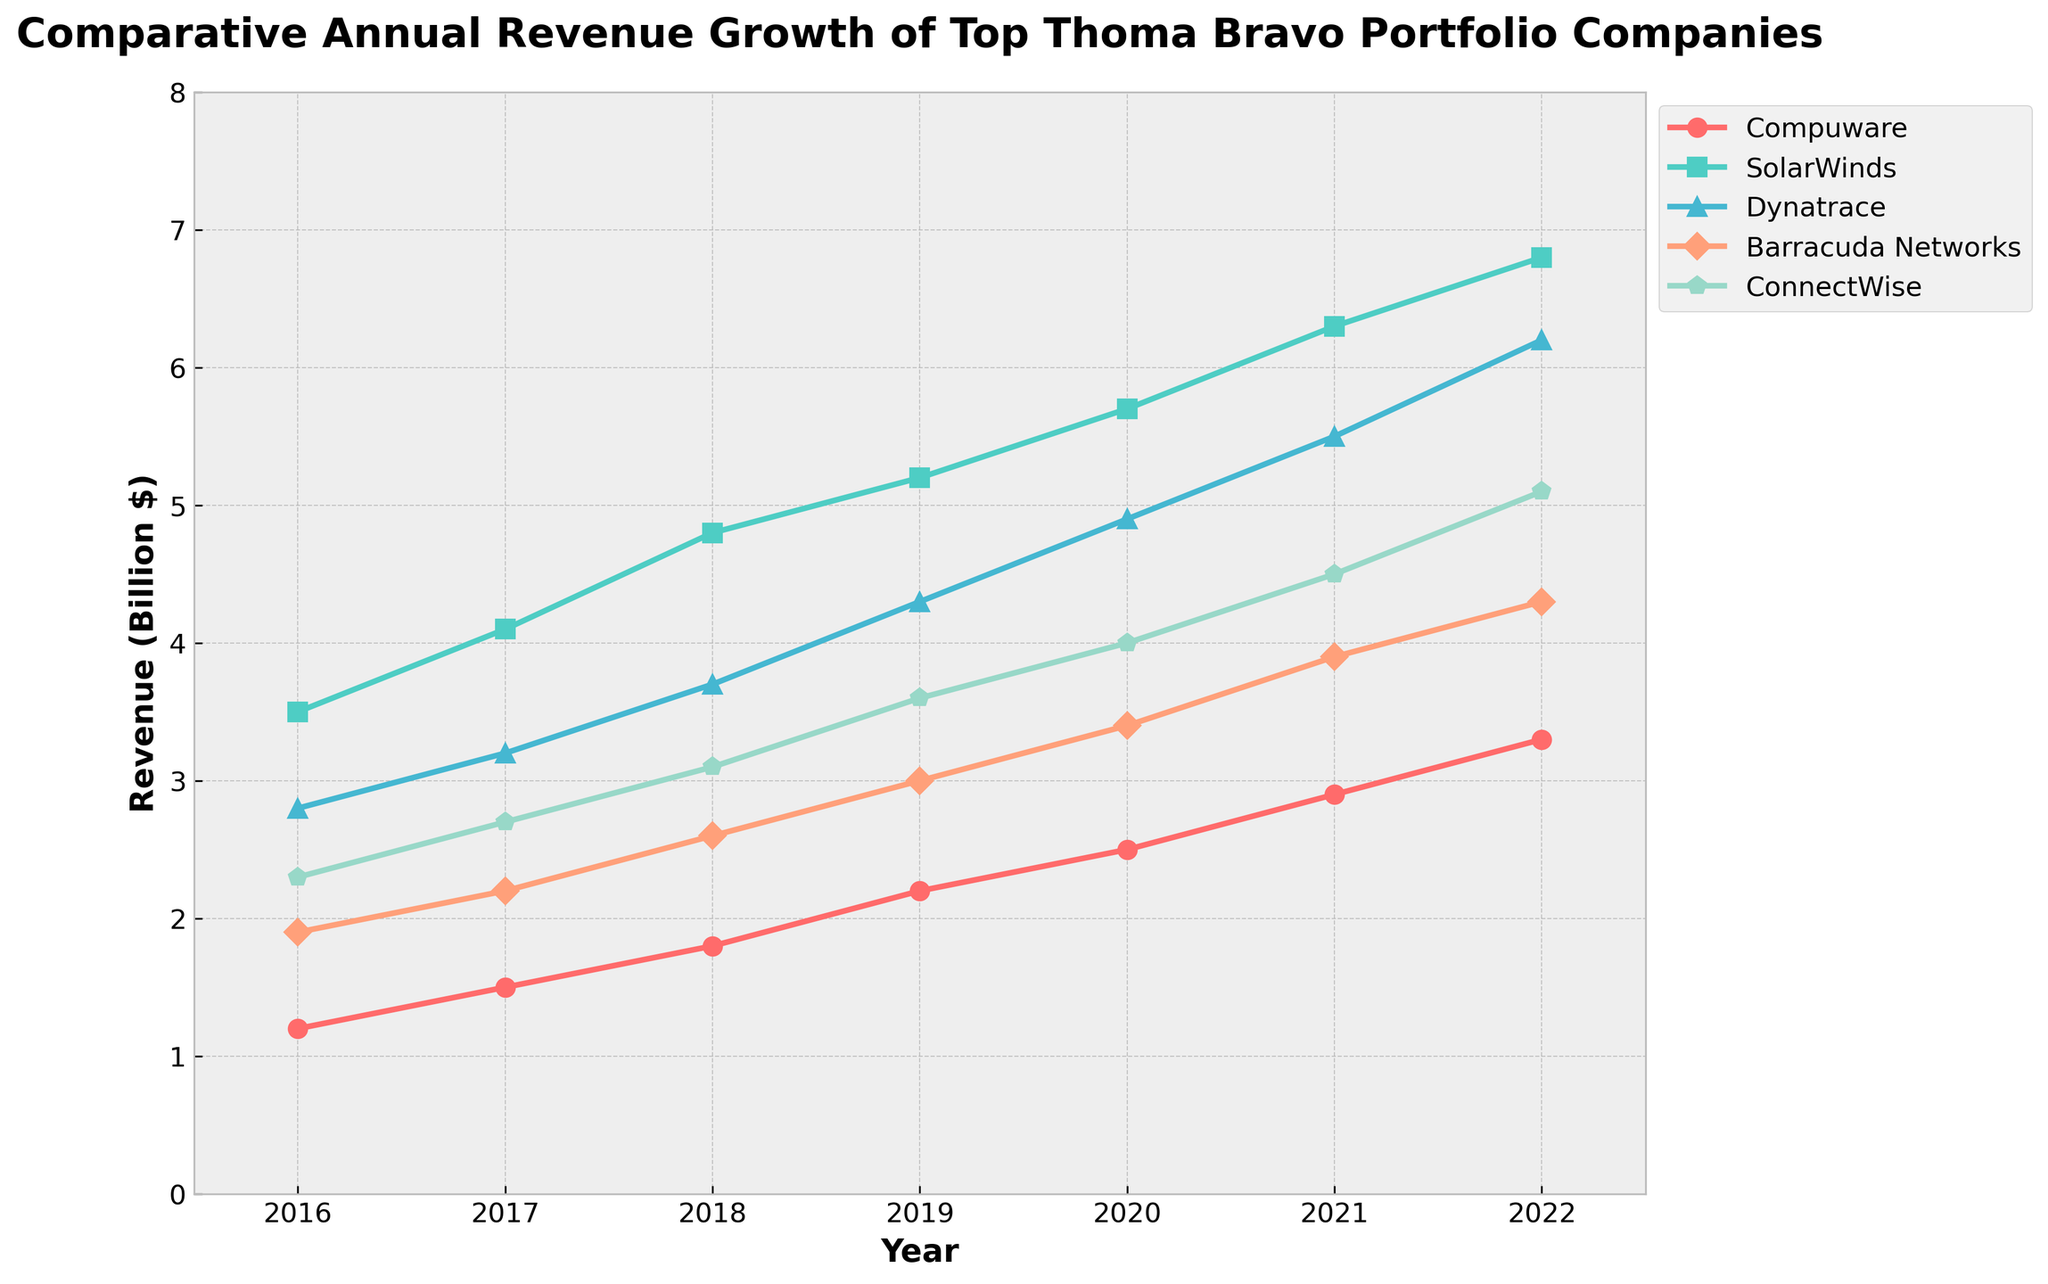Which company had the highest revenue in 2022? By observing the plotted lines for the year 2022 and comparing their end points, we see that SolarWinds had the highest revenue.
Answer: SolarWinds Which company had the least revenue growth from 2016 to 2022? Comparing the difference in revenues from 2016 to 2022 for each company, Compuware went from 1.2 to 3.3, SolarWinds from 3.5 to 6.8, Dynatrace from 2.8 to 6.2, Barracuda Networks from 1.9 to 4.3, and ConnectWise from 2.3 to 5.1. Barracuda Networks shows the least increase (2.4).
Answer: Barracuda Networks Which companies had a revenue of at least 5 billion dollars in 2022? Observing the year 2022 and noting which lines are at or above the 5 billion mark, SolarWinds and Dynatrace meet this criterion.
Answer: SolarWinds, Dynatrace Did any company have a steady (linear) revenue growth from 2016 to 2022? By inspecting the trend of each line across the years, it can be noted that all companies show a generally upward trend; however, no company displays perfectly steady (linear) growth without fluctuations.
Answer: None In which year did Dynatrace surpass a revenue of 4 billion dollars? Following Dynatrace’s growth line across the years, it crosses the 4 billion mark between 2018 and 2019.
Answer: 2019 Which company experienced the highest rate of revenue growth from 2016 to 2022? By comparing the slopes of the lines over the entire period, SolarWinds shows the highest rate of growth, starting at 3.5 and ending at 6.8.
Answer: SolarWinds What is the approximate average revenue of ConnectWise over the years displayed? Adding the revenue values of ConnectWise from 2016 to 2022: 2.3 + 2.7 + 3.1 + 3.6 + 4.0 + 4.5 + 5.1 = 25.3, then dividing by the number of years (7): 25.3 / 7 ≈ 3.61.
Answer: 3.61 Between which consecutive years did Compuware show the greatest increase in revenue? By checking the differences between consecutive years for Compuware: 1.5 - 1.2 = 0.3, 1.8 - 1.5 = 0.3, 2.2 - 1.8 = 0.4, 2.5 - 2.2 = 0.3, 2.9 - 2.5 = 0.4, and 3.3 - 2.9 = 0.4. Compuware had the greatest increase (0.4) between 2018-2019, 2020-2021, and 2021-2022.
Answer: 2018-2019, 2020-2021, 2021-2022 How did SolarWinds' revenue change from 2019 to 2020? Observing SolarWinds’ data points for these years: 5.2 in 2019 and 5.7 in 2020, the revenue increased by 0.5 billion dollars.
Answer: +0.5 billion dollars Which company consistently showed revenue growth every year from 2016 to 2022? Confirming the trend lines for each company year by year, all five companies (Compuware, SolarWinds, Dynatrace, Barracuda Networks, ConnectWise) display a consistently upward trend.
Answer: All (Compuware, SolarWinds, Dynatrace, Barracuda Networks, ConnectWise) 